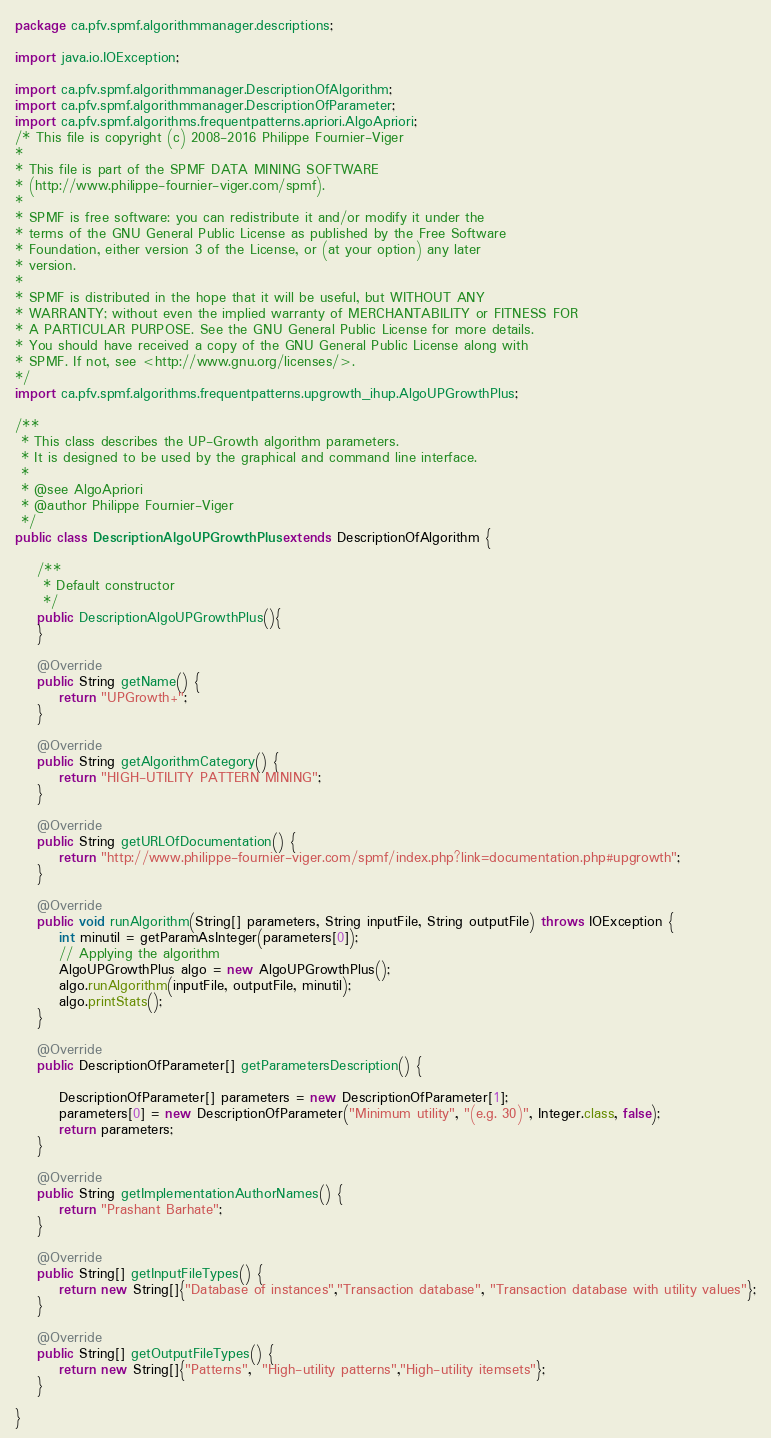Convert code to text. <code><loc_0><loc_0><loc_500><loc_500><_Java_>package ca.pfv.spmf.algorithmmanager.descriptions;

import java.io.IOException;

import ca.pfv.spmf.algorithmmanager.DescriptionOfAlgorithm;
import ca.pfv.spmf.algorithmmanager.DescriptionOfParameter;
import ca.pfv.spmf.algorithms.frequentpatterns.apriori.AlgoApriori;
/* This file is copyright (c) 2008-2016 Philippe Fournier-Viger
* 
* This file is part of the SPMF DATA MINING SOFTWARE
* (http://www.philippe-fournier-viger.com/spmf).
* 
* SPMF is free software: you can redistribute it and/or modify it under the
* terms of the GNU General Public License as published by the Free Software
* Foundation, either version 3 of the License, or (at your option) any later
* version.
* 
* SPMF is distributed in the hope that it will be useful, but WITHOUT ANY
* WARRANTY; without even the implied warranty of MERCHANTABILITY or FITNESS FOR
* A PARTICULAR PURPOSE. See the GNU General Public License for more details.
* You should have received a copy of the GNU General Public License along with
* SPMF. If not, see <http://www.gnu.org/licenses/>.
*/
import ca.pfv.spmf.algorithms.frequentpatterns.upgrowth_ihup.AlgoUPGrowthPlus;

/**
 * This class describes the UP-Growth algorithm parameters. 
 * It is designed to be used by the graphical and command line interface.
 * 
 * @see AlgoApriori
 * @author Philippe Fournier-Viger
 */
public class DescriptionAlgoUPGrowthPlus extends DescriptionOfAlgorithm {

	/**
	 * Default constructor
	 */
	public DescriptionAlgoUPGrowthPlus(){
	}

	@Override
	public String getName() {
		return "UPGrowth+";
	}

	@Override
	public String getAlgorithmCategory() {
		return "HIGH-UTILITY PATTERN MINING";
	}

	@Override
	public String getURLOfDocumentation() {
		return "http://www.philippe-fournier-viger.com/spmf/index.php?link=documentation.php#upgrowth";
	}

	@Override
	public void runAlgorithm(String[] parameters, String inputFile, String outputFile) throws IOException {
		int minutil = getParamAsInteger(parameters[0]);
		// Applying the algorithm
		AlgoUPGrowthPlus algo = new AlgoUPGrowthPlus();
		algo.runAlgorithm(inputFile, outputFile, minutil);
		algo.printStats();
	}

	@Override
	public DescriptionOfParameter[] getParametersDescription() {
        
		DescriptionOfParameter[] parameters = new DescriptionOfParameter[1];
		parameters[0] = new DescriptionOfParameter("Minimum utility", "(e.g. 30)", Integer.class, false);
		return parameters;
	}

	@Override
	public String getImplementationAuthorNames() {
		return "Prashant Barhate";
	}

	@Override
	public String[] getInputFileTypes() {
		return new String[]{"Database of instances","Transaction database", "Transaction database with utility values"};
	}

	@Override
	public String[] getOutputFileTypes() {
		return new String[]{"Patterns",  "High-utility patterns","High-utility itemsets"};
	}
	
}
</code> 